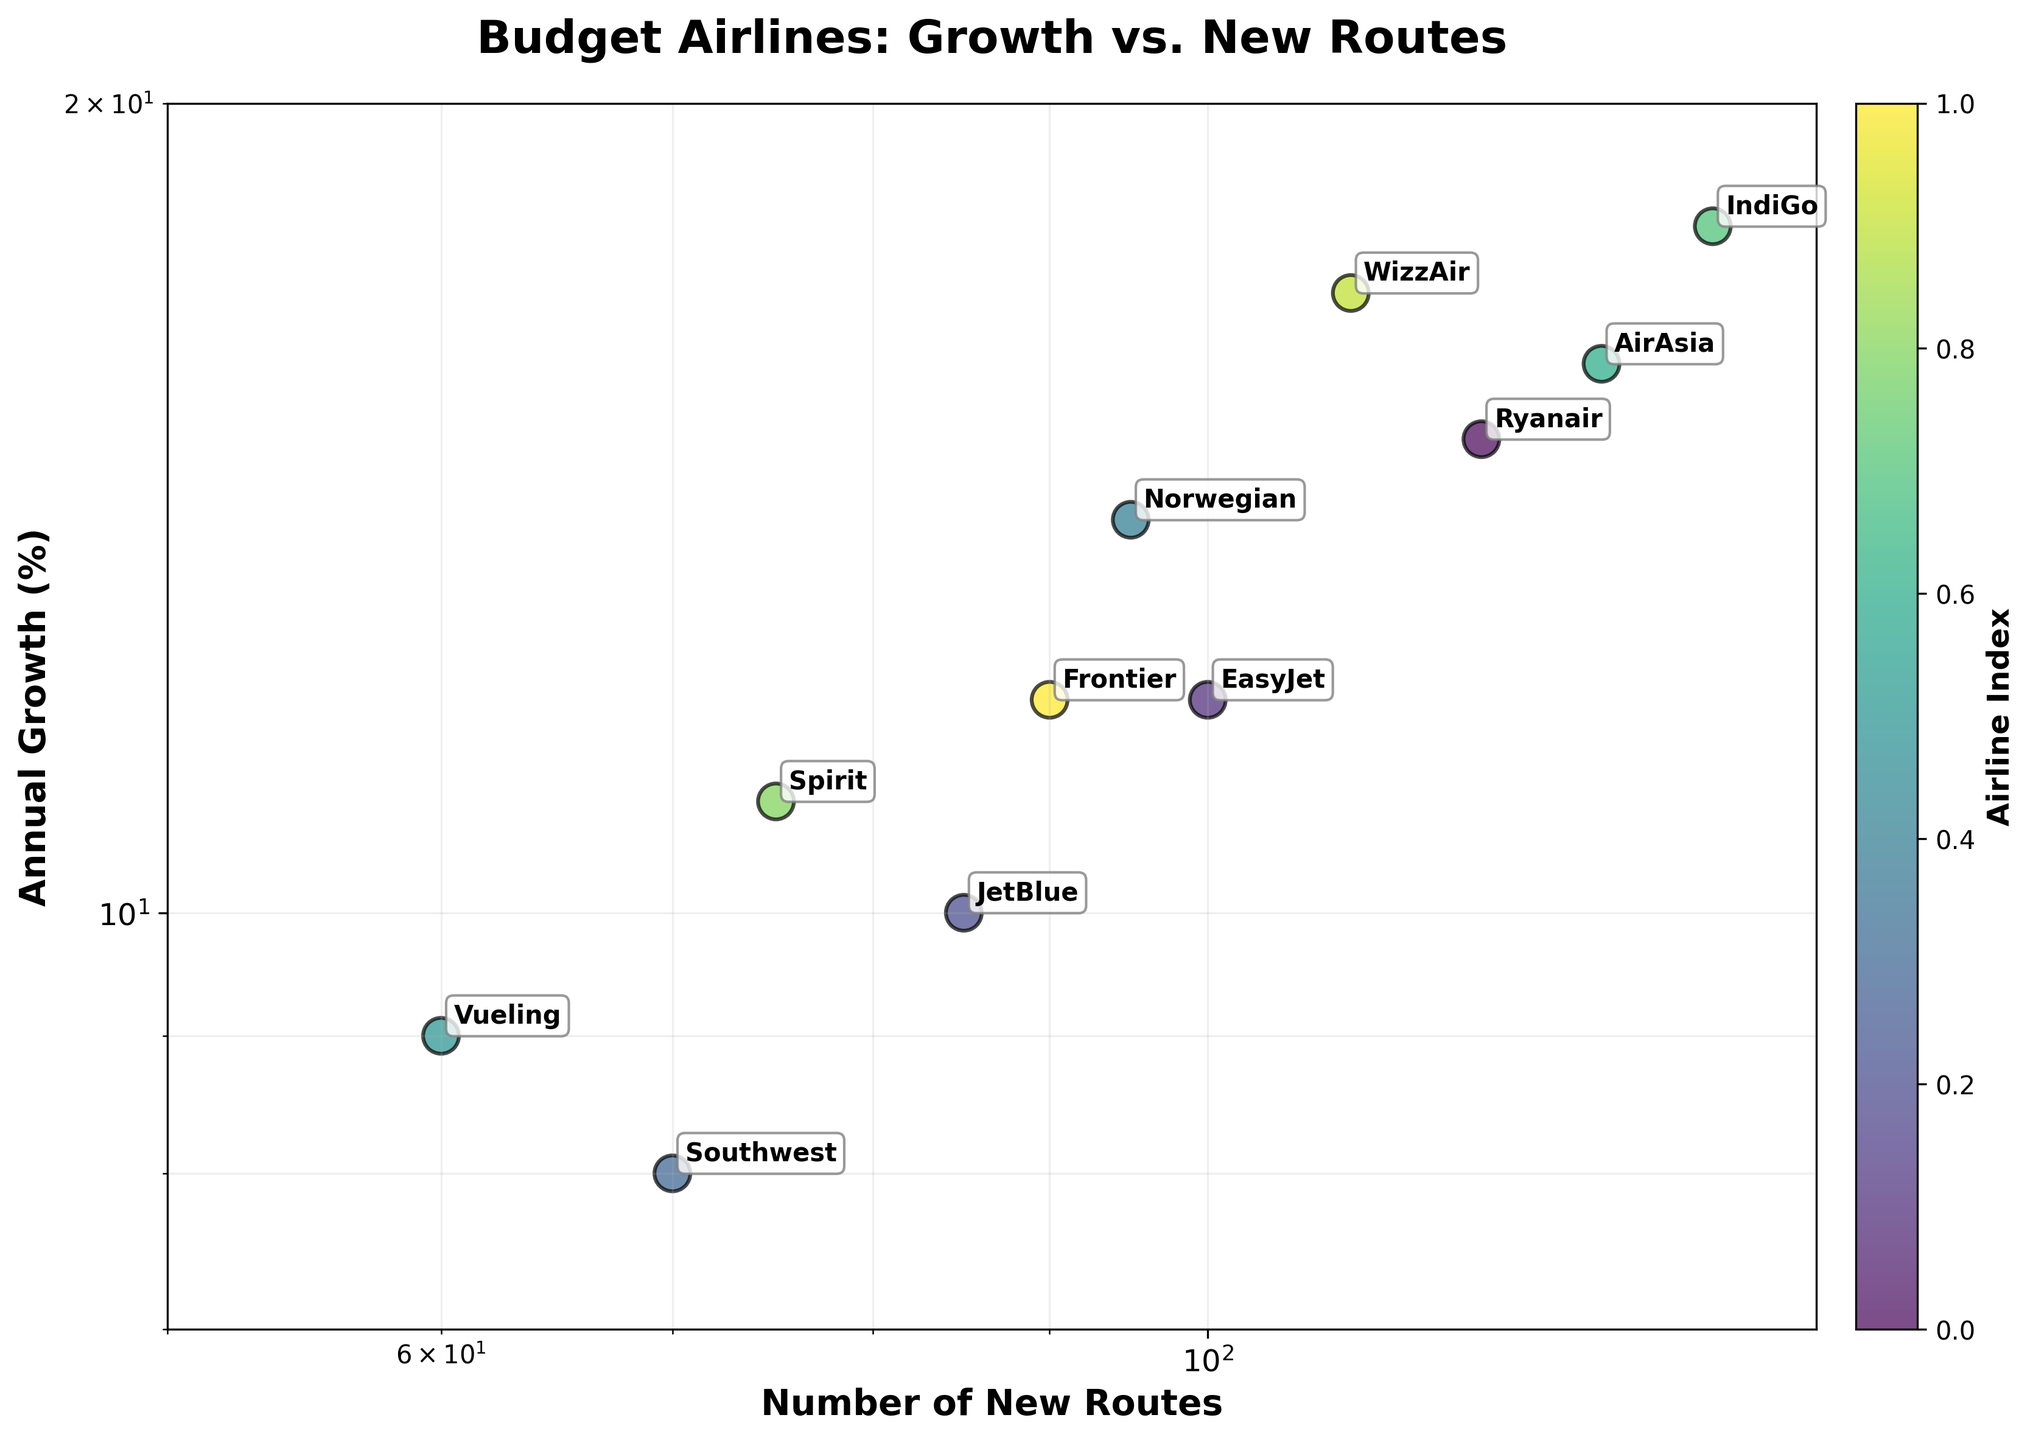What is the title of the scatter plot? The title of the scatter plot is typically displayed at the top of the figure in a larger and bold font than the rest of the text on the plot.
Answer: Budget Airlines: Growth vs. New Routes How many airlines are represented in the scatter plot? Airlines are represented by individual data points, each usually labeled with the airline's name. By counting these labeled data points, you can determine the number of airlines.
Answer: 11 Which airline has the highest annual growth? To find the airline with the highest annual growth, look for the data point that is highest on the vertical axis since the vertical axis represents growth percentages.
Answer: IndiGo What is the range of the x-axis representing the number of new routes? The x-axis range can be determined by looking at the minimum and maximum values marked on the x-axis of the scatter plot.
Answer: 50 to 150 What is the color scheme used in the scatter plot? The scatter plot uses a color gradient to differentiate data points. You can identify the color scheme by examining the legend or color bar on the plot.
Answer: Viridis Which airline is close to EasyJet in terms of annual growth but has more new routes introduced? To answer this, find EasyJet's data point and look for another data point that is vertically aligned (similar growth) but horizontally to the right (more new routes).
Answer: Norwegian Which airlines have an annual growth between 10% and 15%? To find this, look at data points that fall within this range on the vertical axis and identify the corresponding airline labels.
Answer: JetBlue, Norwegian, Spirit, Frontier What is the difference in the number of new routes between AirAsia and Ryanair? First, locate the data points for AirAsia and Ryanair. Then, read their respective x-axis values and calculate the difference.
Answer: 10 routes If you average the annual growth of WizzAir and Spirit, what is the result? Find the growth percentages for both WizzAir and Spirit, sum them up, and divide by 2 to get the average.
Answer: (17 + 11) / 2 = 14% What pattern can you observe regarding the relationship between annual growth and the number of new routes introduced? Observe the overall trend formed by the data points. Since annual growth and new routes are plotted on logarithmic scales, describe any visible correlation.
Answer: Positive correlation: more new routes often align with higher growth percentages 